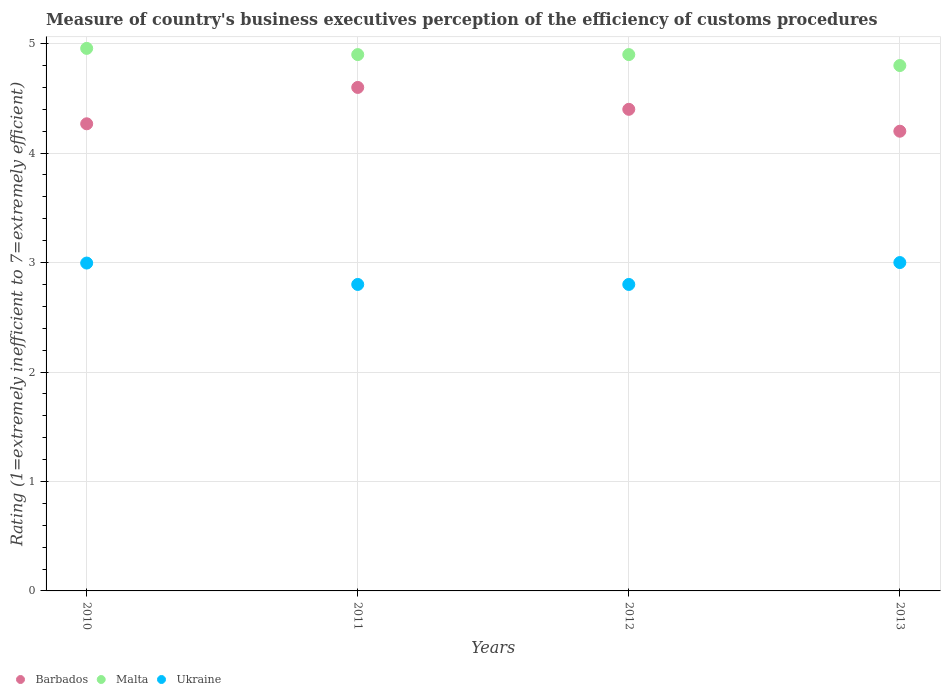How many different coloured dotlines are there?
Your response must be concise. 3. Is the number of dotlines equal to the number of legend labels?
Offer a terse response. Yes. Across all years, what is the maximum rating of the efficiency of customs procedure in Malta?
Offer a very short reply. 4.96. In which year was the rating of the efficiency of customs procedure in Malta maximum?
Your answer should be very brief. 2010. In which year was the rating of the efficiency of customs procedure in Malta minimum?
Provide a succinct answer. 2013. What is the total rating of the efficiency of customs procedure in Malta in the graph?
Make the answer very short. 19.56. What is the difference between the rating of the efficiency of customs procedure in Ukraine in 2010 and that in 2013?
Provide a succinct answer. -0. What is the difference between the rating of the efficiency of customs procedure in Barbados in 2011 and the rating of the efficiency of customs procedure in Ukraine in 2010?
Provide a succinct answer. 1.6. What is the average rating of the efficiency of customs procedure in Malta per year?
Your answer should be very brief. 4.89. In the year 2013, what is the difference between the rating of the efficiency of customs procedure in Barbados and rating of the efficiency of customs procedure in Malta?
Your answer should be compact. -0.6. What is the ratio of the rating of the efficiency of customs procedure in Barbados in 2011 to that in 2013?
Ensure brevity in your answer.  1.1. Is the rating of the efficiency of customs procedure in Ukraine in 2010 less than that in 2012?
Your answer should be very brief. No. What is the difference between the highest and the second highest rating of the efficiency of customs procedure in Barbados?
Your response must be concise. 0.2. What is the difference between the highest and the lowest rating of the efficiency of customs procedure in Barbados?
Offer a very short reply. 0.4. Does the rating of the efficiency of customs procedure in Malta monotonically increase over the years?
Make the answer very short. No. Is the rating of the efficiency of customs procedure in Barbados strictly less than the rating of the efficiency of customs procedure in Ukraine over the years?
Offer a very short reply. No. How many years are there in the graph?
Make the answer very short. 4. Does the graph contain any zero values?
Provide a succinct answer. No. How are the legend labels stacked?
Offer a very short reply. Horizontal. What is the title of the graph?
Provide a short and direct response. Measure of country's business executives perception of the efficiency of customs procedures. Does "Cuba" appear as one of the legend labels in the graph?
Your answer should be very brief. No. What is the label or title of the Y-axis?
Make the answer very short. Rating (1=extremely inefficient to 7=extremely efficient). What is the Rating (1=extremely inefficient to 7=extremely efficient) of Barbados in 2010?
Offer a terse response. 4.27. What is the Rating (1=extremely inefficient to 7=extremely efficient) of Malta in 2010?
Your answer should be compact. 4.96. What is the Rating (1=extremely inefficient to 7=extremely efficient) in Ukraine in 2010?
Your answer should be very brief. 3. What is the Rating (1=extremely inefficient to 7=extremely efficient) of Malta in 2011?
Your answer should be compact. 4.9. What is the Rating (1=extremely inefficient to 7=extremely efficient) in Ukraine in 2011?
Your response must be concise. 2.8. What is the Rating (1=extremely inefficient to 7=extremely efficient) of Barbados in 2012?
Provide a succinct answer. 4.4. What is the Rating (1=extremely inefficient to 7=extremely efficient) of Ukraine in 2012?
Offer a very short reply. 2.8. What is the Rating (1=extremely inefficient to 7=extremely efficient) of Malta in 2013?
Provide a short and direct response. 4.8. Across all years, what is the maximum Rating (1=extremely inefficient to 7=extremely efficient) in Barbados?
Provide a succinct answer. 4.6. Across all years, what is the maximum Rating (1=extremely inefficient to 7=extremely efficient) of Malta?
Give a very brief answer. 4.96. Across all years, what is the maximum Rating (1=extremely inefficient to 7=extremely efficient) of Ukraine?
Your answer should be compact. 3. Across all years, what is the minimum Rating (1=extremely inefficient to 7=extremely efficient) in Barbados?
Provide a succinct answer. 4.2. What is the total Rating (1=extremely inefficient to 7=extremely efficient) in Barbados in the graph?
Your answer should be very brief. 17.47. What is the total Rating (1=extremely inefficient to 7=extremely efficient) of Malta in the graph?
Your response must be concise. 19.56. What is the total Rating (1=extremely inefficient to 7=extremely efficient) of Ukraine in the graph?
Ensure brevity in your answer.  11.6. What is the difference between the Rating (1=extremely inefficient to 7=extremely efficient) of Barbados in 2010 and that in 2011?
Provide a succinct answer. -0.33. What is the difference between the Rating (1=extremely inefficient to 7=extremely efficient) of Malta in 2010 and that in 2011?
Provide a short and direct response. 0.06. What is the difference between the Rating (1=extremely inefficient to 7=extremely efficient) in Ukraine in 2010 and that in 2011?
Ensure brevity in your answer.  0.2. What is the difference between the Rating (1=extremely inefficient to 7=extremely efficient) in Barbados in 2010 and that in 2012?
Make the answer very short. -0.13. What is the difference between the Rating (1=extremely inefficient to 7=extremely efficient) in Malta in 2010 and that in 2012?
Make the answer very short. 0.06. What is the difference between the Rating (1=extremely inefficient to 7=extremely efficient) in Ukraine in 2010 and that in 2012?
Offer a terse response. 0.2. What is the difference between the Rating (1=extremely inefficient to 7=extremely efficient) in Barbados in 2010 and that in 2013?
Ensure brevity in your answer.  0.07. What is the difference between the Rating (1=extremely inefficient to 7=extremely efficient) in Malta in 2010 and that in 2013?
Provide a short and direct response. 0.16. What is the difference between the Rating (1=extremely inefficient to 7=extremely efficient) of Ukraine in 2010 and that in 2013?
Keep it short and to the point. -0. What is the difference between the Rating (1=extremely inefficient to 7=extremely efficient) in Barbados in 2011 and that in 2013?
Your answer should be very brief. 0.4. What is the difference between the Rating (1=extremely inefficient to 7=extremely efficient) in Ukraine in 2012 and that in 2013?
Provide a short and direct response. -0.2. What is the difference between the Rating (1=extremely inefficient to 7=extremely efficient) of Barbados in 2010 and the Rating (1=extremely inefficient to 7=extremely efficient) of Malta in 2011?
Your response must be concise. -0.63. What is the difference between the Rating (1=extremely inefficient to 7=extremely efficient) in Barbados in 2010 and the Rating (1=extremely inefficient to 7=extremely efficient) in Ukraine in 2011?
Give a very brief answer. 1.47. What is the difference between the Rating (1=extremely inefficient to 7=extremely efficient) in Malta in 2010 and the Rating (1=extremely inefficient to 7=extremely efficient) in Ukraine in 2011?
Offer a very short reply. 2.16. What is the difference between the Rating (1=extremely inefficient to 7=extremely efficient) in Barbados in 2010 and the Rating (1=extremely inefficient to 7=extremely efficient) in Malta in 2012?
Provide a short and direct response. -0.63. What is the difference between the Rating (1=extremely inefficient to 7=extremely efficient) of Barbados in 2010 and the Rating (1=extremely inefficient to 7=extremely efficient) of Ukraine in 2012?
Provide a short and direct response. 1.47. What is the difference between the Rating (1=extremely inefficient to 7=extremely efficient) of Malta in 2010 and the Rating (1=extremely inefficient to 7=extremely efficient) of Ukraine in 2012?
Your answer should be very brief. 2.16. What is the difference between the Rating (1=extremely inefficient to 7=extremely efficient) in Barbados in 2010 and the Rating (1=extremely inefficient to 7=extremely efficient) in Malta in 2013?
Provide a short and direct response. -0.53. What is the difference between the Rating (1=extremely inefficient to 7=extremely efficient) in Barbados in 2010 and the Rating (1=extremely inefficient to 7=extremely efficient) in Ukraine in 2013?
Offer a terse response. 1.27. What is the difference between the Rating (1=extremely inefficient to 7=extremely efficient) of Malta in 2010 and the Rating (1=extremely inefficient to 7=extremely efficient) of Ukraine in 2013?
Ensure brevity in your answer.  1.96. What is the difference between the Rating (1=extremely inefficient to 7=extremely efficient) in Barbados in 2011 and the Rating (1=extremely inefficient to 7=extremely efficient) in Malta in 2012?
Ensure brevity in your answer.  -0.3. What is the difference between the Rating (1=extremely inefficient to 7=extremely efficient) of Barbados in 2011 and the Rating (1=extremely inefficient to 7=extremely efficient) of Ukraine in 2012?
Offer a terse response. 1.8. What is the difference between the Rating (1=extremely inefficient to 7=extremely efficient) of Malta in 2011 and the Rating (1=extremely inefficient to 7=extremely efficient) of Ukraine in 2012?
Offer a terse response. 2.1. What is the difference between the Rating (1=extremely inefficient to 7=extremely efficient) in Barbados in 2012 and the Rating (1=extremely inefficient to 7=extremely efficient) in Malta in 2013?
Offer a terse response. -0.4. What is the difference between the Rating (1=extremely inefficient to 7=extremely efficient) in Malta in 2012 and the Rating (1=extremely inefficient to 7=extremely efficient) in Ukraine in 2013?
Your response must be concise. 1.9. What is the average Rating (1=extremely inefficient to 7=extremely efficient) of Barbados per year?
Give a very brief answer. 4.37. What is the average Rating (1=extremely inefficient to 7=extremely efficient) of Malta per year?
Provide a succinct answer. 4.89. What is the average Rating (1=extremely inefficient to 7=extremely efficient) of Ukraine per year?
Offer a terse response. 2.9. In the year 2010, what is the difference between the Rating (1=extremely inefficient to 7=extremely efficient) of Barbados and Rating (1=extremely inefficient to 7=extremely efficient) of Malta?
Provide a short and direct response. -0.69. In the year 2010, what is the difference between the Rating (1=extremely inefficient to 7=extremely efficient) of Barbados and Rating (1=extremely inefficient to 7=extremely efficient) of Ukraine?
Make the answer very short. 1.27. In the year 2010, what is the difference between the Rating (1=extremely inefficient to 7=extremely efficient) of Malta and Rating (1=extremely inefficient to 7=extremely efficient) of Ukraine?
Offer a terse response. 1.96. In the year 2011, what is the difference between the Rating (1=extremely inefficient to 7=extremely efficient) in Barbados and Rating (1=extremely inefficient to 7=extremely efficient) in Ukraine?
Offer a very short reply. 1.8. In the year 2012, what is the difference between the Rating (1=extremely inefficient to 7=extremely efficient) in Barbados and Rating (1=extremely inefficient to 7=extremely efficient) in Ukraine?
Offer a terse response. 1.6. In the year 2013, what is the difference between the Rating (1=extremely inefficient to 7=extremely efficient) in Barbados and Rating (1=extremely inefficient to 7=extremely efficient) in Ukraine?
Your answer should be very brief. 1.2. What is the ratio of the Rating (1=extremely inefficient to 7=extremely efficient) of Barbados in 2010 to that in 2011?
Your response must be concise. 0.93. What is the ratio of the Rating (1=extremely inefficient to 7=extremely efficient) of Malta in 2010 to that in 2011?
Ensure brevity in your answer.  1.01. What is the ratio of the Rating (1=extremely inefficient to 7=extremely efficient) in Ukraine in 2010 to that in 2011?
Offer a very short reply. 1.07. What is the ratio of the Rating (1=extremely inefficient to 7=extremely efficient) of Barbados in 2010 to that in 2012?
Your answer should be compact. 0.97. What is the ratio of the Rating (1=extremely inefficient to 7=extremely efficient) of Malta in 2010 to that in 2012?
Your answer should be very brief. 1.01. What is the ratio of the Rating (1=extremely inefficient to 7=extremely efficient) of Ukraine in 2010 to that in 2012?
Offer a terse response. 1.07. What is the ratio of the Rating (1=extremely inefficient to 7=extremely efficient) of Barbados in 2010 to that in 2013?
Make the answer very short. 1.02. What is the ratio of the Rating (1=extremely inefficient to 7=extremely efficient) of Malta in 2010 to that in 2013?
Your response must be concise. 1.03. What is the ratio of the Rating (1=extremely inefficient to 7=extremely efficient) of Barbados in 2011 to that in 2012?
Offer a very short reply. 1.05. What is the ratio of the Rating (1=extremely inefficient to 7=extremely efficient) in Malta in 2011 to that in 2012?
Offer a terse response. 1. What is the ratio of the Rating (1=extremely inefficient to 7=extremely efficient) of Barbados in 2011 to that in 2013?
Your response must be concise. 1.1. What is the ratio of the Rating (1=extremely inefficient to 7=extremely efficient) of Malta in 2011 to that in 2013?
Offer a terse response. 1.02. What is the ratio of the Rating (1=extremely inefficient to 7=extremely efficient) of Barbados in 2012 to that in 2013?
Your answer should be compact. 1.05. What is the ratio of the Rating (1=extremely inefficient to 7=extremely efficient) in Malta in 2012 to that in 2013?
Your answer should be compact. 1.02. What is the difference between the highest and the second highest Rating (1=extremely inefficient to 7=extremely efficient) of Barbados?
Your response must be concise. 0.2. What is the difference between the highest and the second highest Rating (1=extremely inefficient to 7=extremely efficient) of Malta?
Provide a short and direct response. 0.06. What is the difference between the highest and the second highest Rating (1=extremely inefficient to 7=extremely efficient) of Ukraine?
Provide a succinct answer. 0. What is the difference between the highest and the lowest Rating (1=extremely inefficient to 7=extremely efficient) of Barbados?
Your response must be concise. 0.4. What is the difference between the highest and the lowest Rating (1=extremely inefficient to 7=extremely efficient) in Malta?
Your answer should be compact. 0.16. What is the difference between the highest and the lowest Rating (1=extremely inefficient to 7=extremely efficient) in Ukraine?
Your response must be concise. 0.2. 